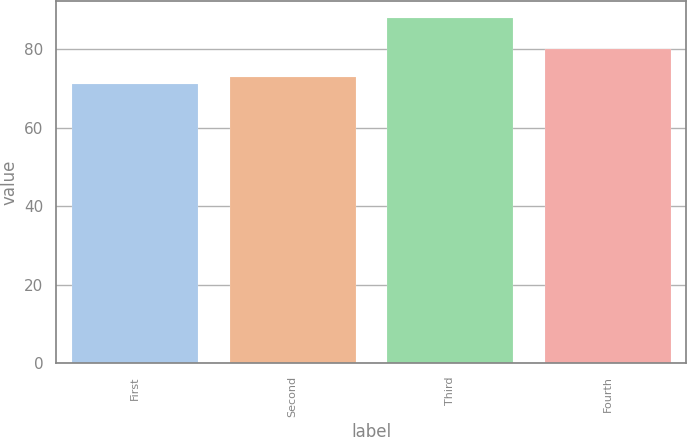Convert chart to OTSL. <chart><loc_0><loc_0><loc_500><loc_500><bar_chart><fcel>First<fcel>Second<fcel>Third<fcel>Fourth<nl><fcel>71.2<fcel>73<fcel>87.99<fcel>80<nl></chart> 